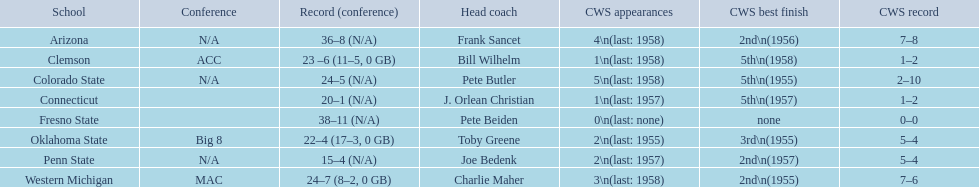What was the smallest number of wins documented by the team with the highest number of defeats? 15–4 (N/A). Which team possessed this record? Penn State. 